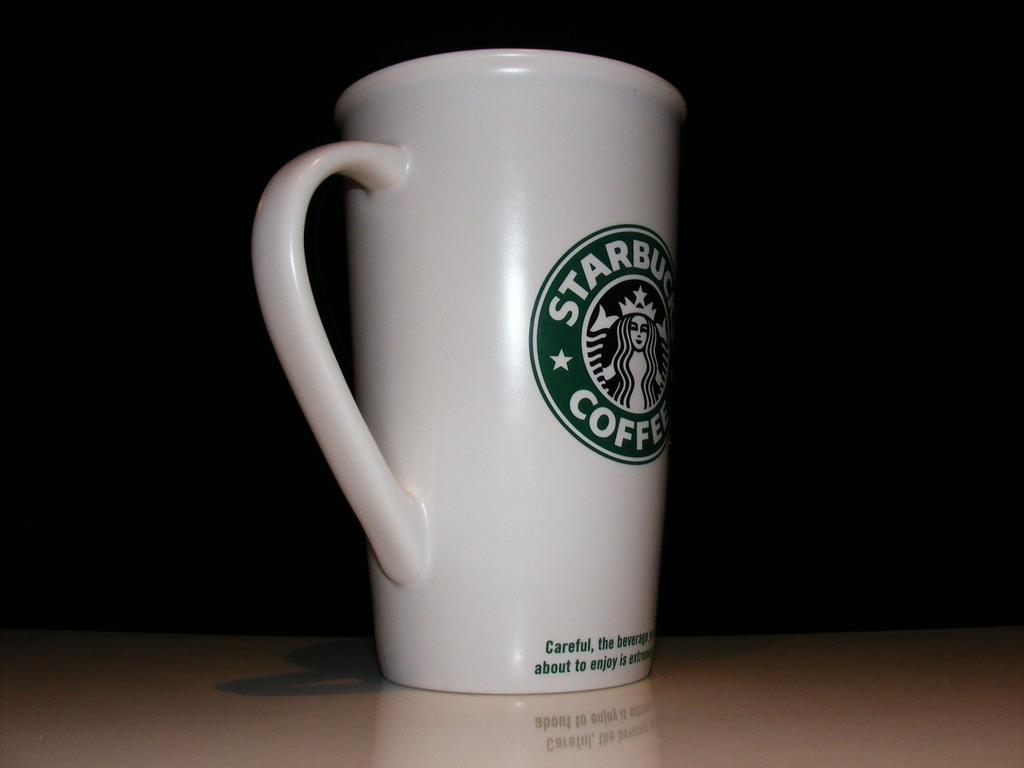Provide a one-sentence caption for the provided image. A tall ceramic cup that is from starbucks and made for coffee. 